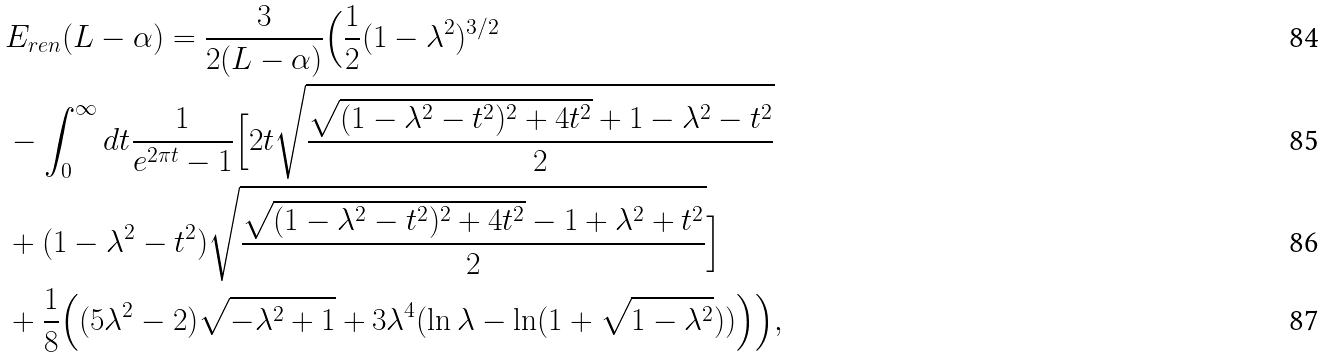<formula> <loc_0><loc_0><loc_500><loc_500>& E _ { r e n } ( L - \alpha ) = \frac { 3 } { 2 ( L - \alpha ) } \Big { ( } \frac { 1 } { 2 } ( 1 - \lambda ^ { 2 } ) ^ { 3 / 2 } \\ & - \int _ { 0 } ^ { \infty } d t \frac { 1 } { e ^ { 2 \pi t } - 1 } \Big { [ } 2 t \sqrt { \frac { \sqrt { ( 1 - \lambda ^ { 2 } - t ^ { 2 } ) ^ { 2 } + 4 t ^ { 2 } } + 1 - \lambda ^ { 2 } - t ^ { 2 } } { 2 } } \\ & + ( 1 - \lambda ^ { 2 } - t ^ { 2 } ) \sqrt { \frac { \sqrt { ( 1 - \lambda ^ { 2 } - t ^ { 2 } ) ^ { 2 } + 4 t ^ { 2 } } - 1 + \lambda ^ { 2 } + t ^ { 2 } } { 2 } } \Big { ] } \\ & + \frac { 1 } { 8 } \Big { ( } ( 5 \lambda ^ { 2 } - 2 ) \sqrt { - \lambda ^ { 2 } + 1 } + 3 \lambda ^ { 4 } ( \ln \lambda - \ln ( 1 + \sqrt { 1 - \lambda ^ { 2 } } ) ) \Big { ) } \Big { ) } ,</formula> 